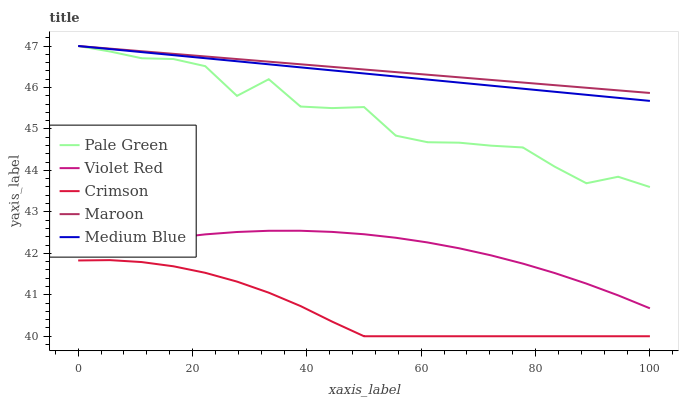Does Crimson have the minimum area under the curve?
Answer yes or no. Yes. Does Maroon have the maximum area under the curve?
Answer yes or no. Yes. Does Violet Red have the minimum area under the curve?
Answer yes or no. No. Does Violet Red have the maximum area under the curve?
Answer yes or no. No. Is Maroon the smoothest?
Answer yes or no. Yes. Is Pale Green the roughest?
Answer yes or no. Yes. Is Violet Red the smoothest?
Answer yes or no. No. Is Violet Red the roughest?
Answer yes or no. No. Does Violet Red have the lowest value?
Answer yes or no. No. Does Violet Red have the highest value?
Answer yes or no. No. Is Violet Red less than Pale Green?
Answer yes or no. Yes. Is Maroon greater than Crimson?
Answer yes or no. Yes. Does Violet Red intersect Pale Green?
Answer yes or no. No. 